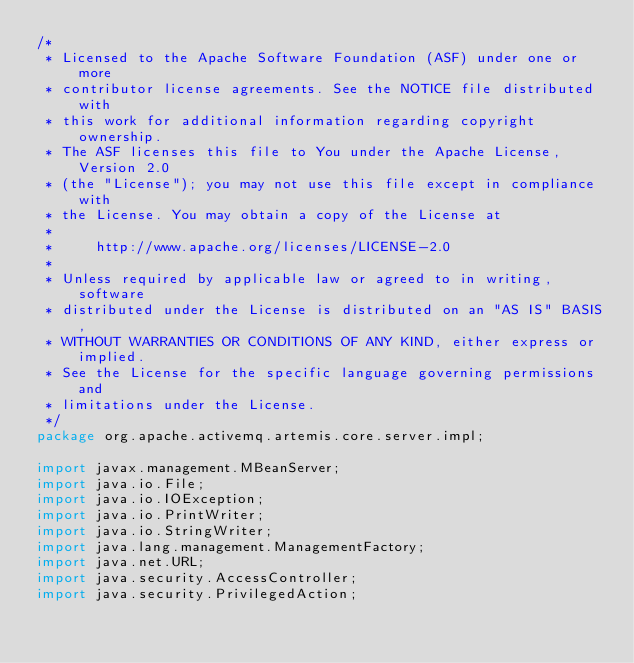<code> <loc_0><loc_0><loc_500><loc_500><_Java_>/*
 * Licensed to the Apache Software Foundation (ASF) under one or more
 * contributor license agreements. See the NOTICE file distributed with
 * this work for additional information regarding copyright ownership.
 * The ASF licenses this file to You under the Apache License, Version 2.0
 * (the "License"); you may not use this file except in compliance with
 * the License. You may obtain a copy of the License at
 *
 *     http://www.apache.org/licenses/LICENSE-2.0
 *
 * Unless required by applicable law or agreed to in writing, software
 * distributed under the License is distributed on an "AS IS" BASIS,
 * WITHOUT WARRANTIES OR CONDITIONS OF ANY KIND, either express or implied.
 * See the License for the specific language governing permissions and
 * limitations under the License.
 */
package org.apache.activemq.artemis.core.server.impl;

import javax.management.MBeanServer;
import java.io.File;
import java.io.IOException;
import java.io.PrintWriter;
import java.io.StringWriter;
import java.lang.management.ManagementFactory;
import java.net.URL;
import java.security.AccessController;
import java.security.PrivilegedAction;</code> 